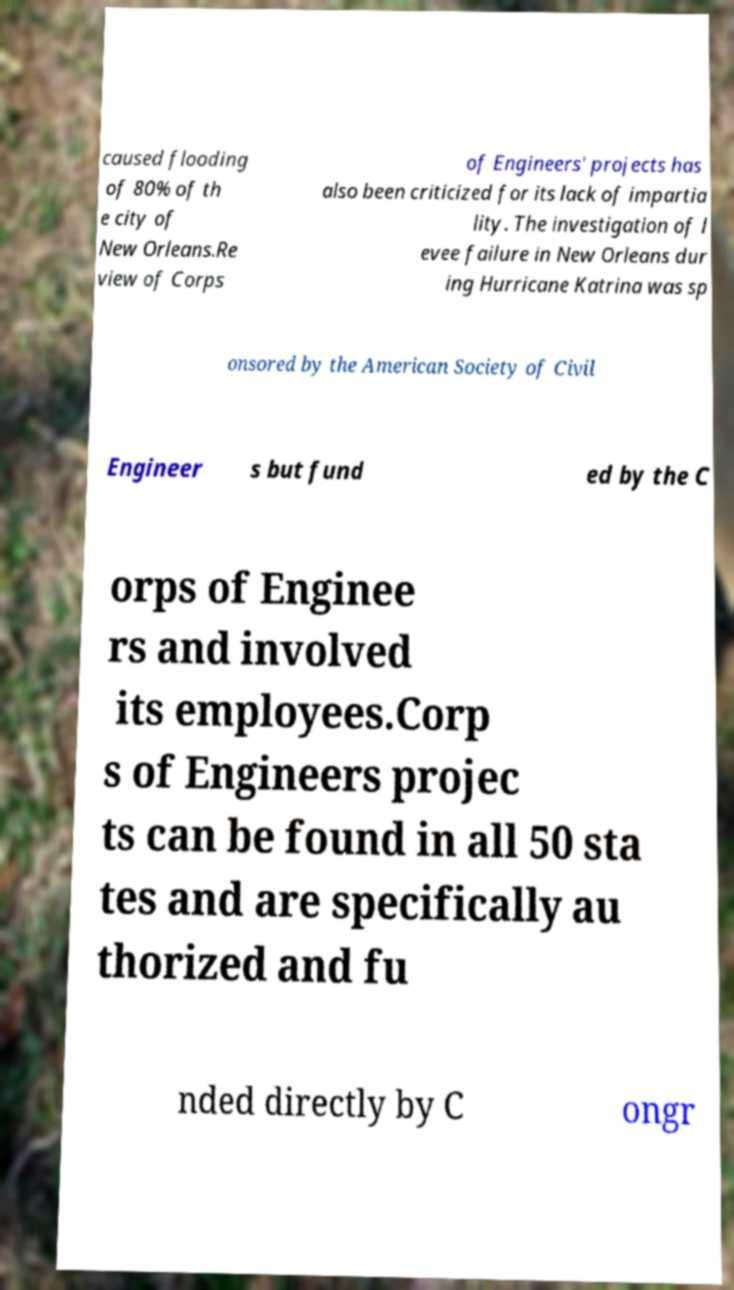What messages or text are displayed in this image? I need them in a readable, typed format. caused flooding of 80% of th e city of New Orleans.Re view of Corps of Engineers' projects has also been criticized for its lack of impartia lity. The investigation of l evee failure in New Orleans dur ing Hurricane Katrina was sp onsored by the American Society of Civil Engineer s but fund ed by the C orps of Enginee rs and involved its employees.Corp s of Engineers projec ts can be found in all 50 sta tes and are specifically au thorized and fu nded directly by C ongr 